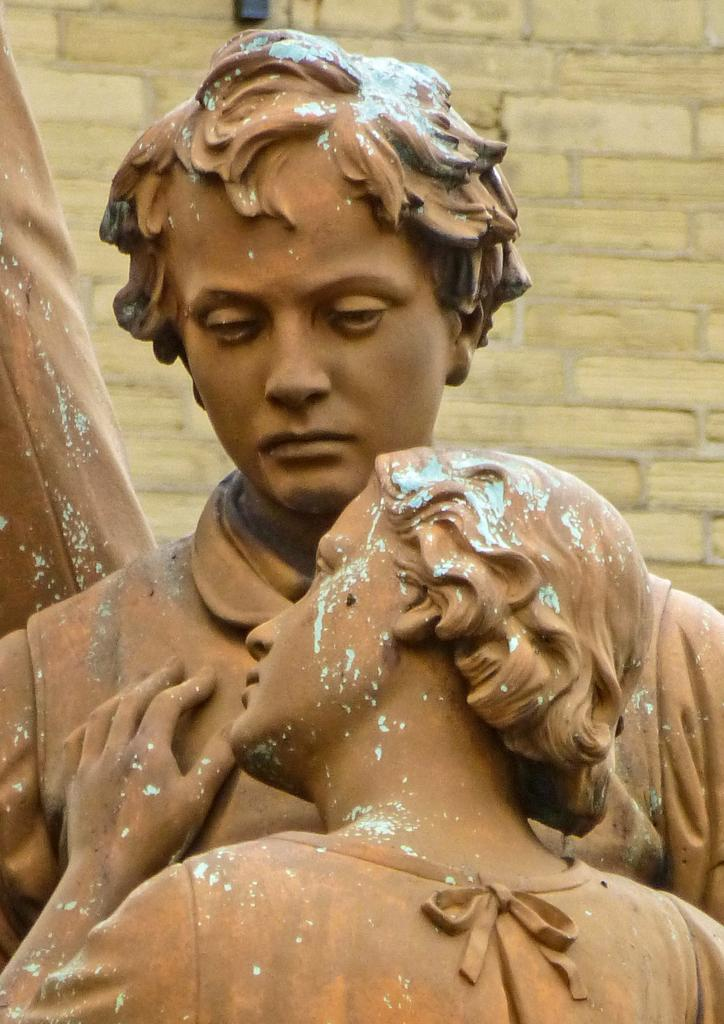What is the main subject in the image? There is a statue in the image. Can you describe the setting of the image? There is a wall in the background of the image. Can you see any worms crawling on the statue in the image? There are no worms present in the image. 